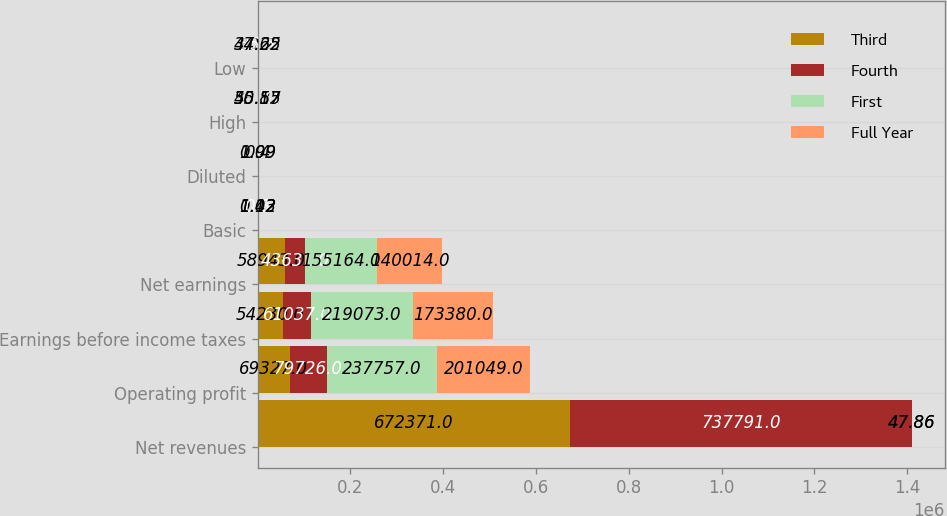<chart> <loc_0><loc_0><loc_500><loc_500><stacked_bar_chart><ecel><fcel>Net revenues<fcel>Operating profit<fcel>Earnings before income taxes<fcel>Net earnings<fcel>Basic<fcel>Diluted<fcel>High<fcel>Low<nl><fcel>Third<fcel>672371<fcel>69327<fcel>54230<fcel>58943<fcel>0.43<fcel>0.4<fcel>38.82<fcel>30.2<nl><fcel>Fourth<fcel>737791<fcel>79726<fcel>61037<fcel>43631<fcel>0.3<fcel>0.29<fcel>43.71<fcel>36.5<nl><fcel>First<fcel>47.86<fcel>237757<fcel>219073<fcel>155164<fcel>1.12<fcel>1.09<fcel>45.55<fcel>37.65<nl><fcel>Full Year<fcel>47.86<fcel>201049<fcel>173380<fcel>140014<fcel>1.02<fcel>0.99<fcel>50.17<fcel>44.22<nl></chart> 